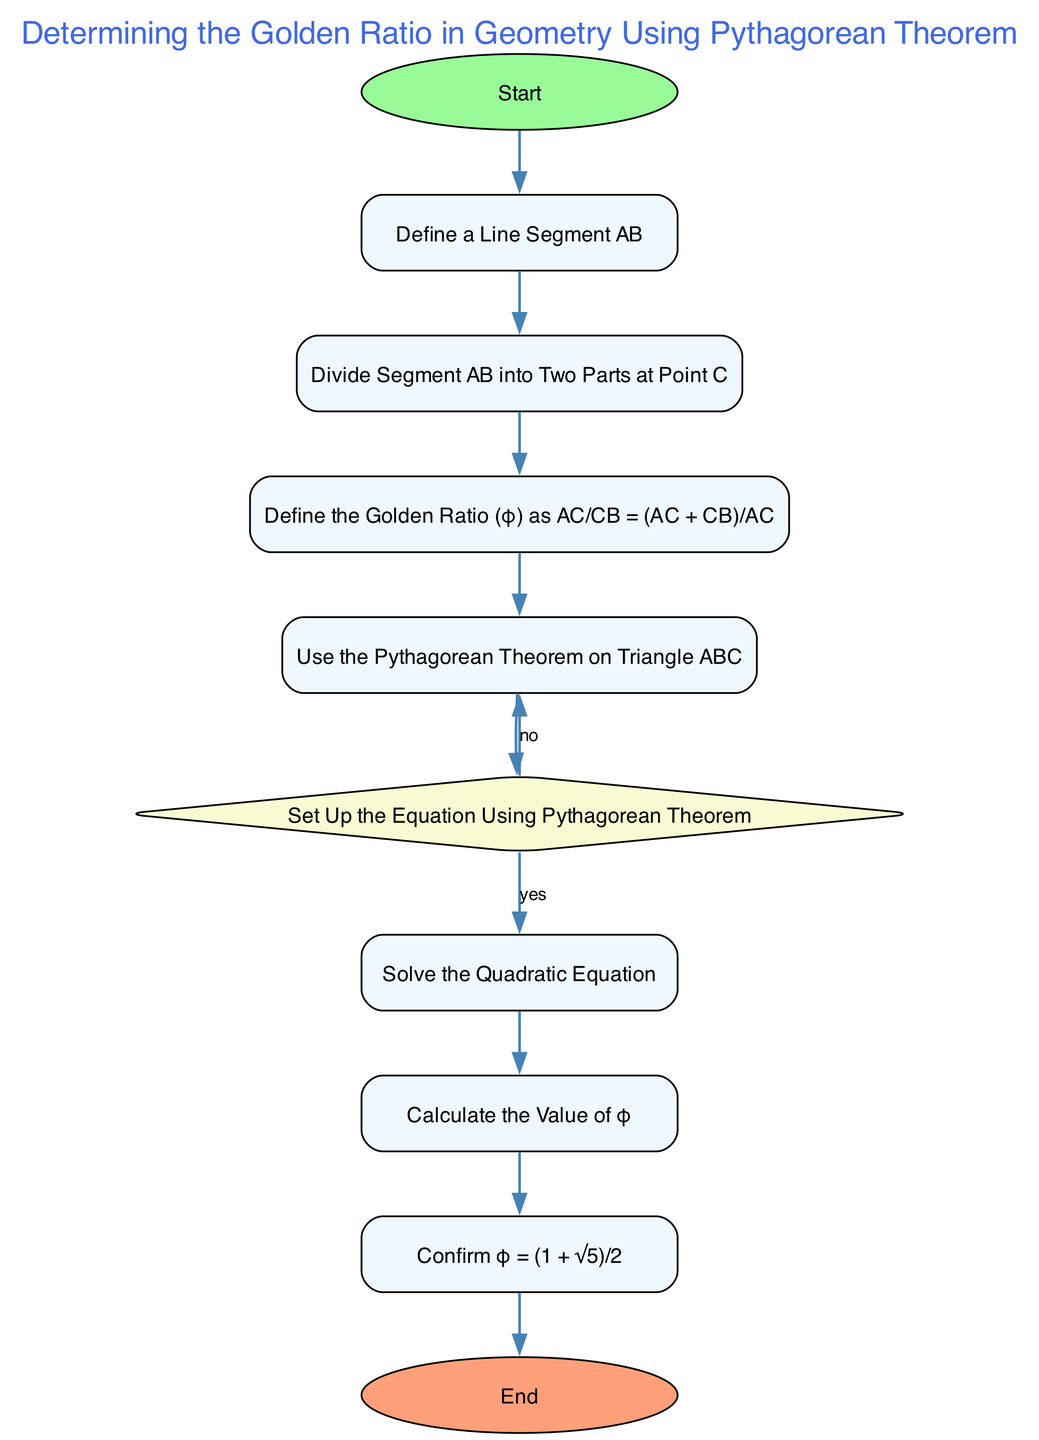What is the first step in the flowchart? The first step is labeled "Start." This is where the process begins in the flowchart.
Answer: Start How many process steps are in the diagram? The diagram contains six process steps: "Define a Line Segment AB," "Divide Segment AB into Two Parts at Point C," "Define the Golden Ratio (φ) as AC/CB = (AC + CB)/AC," "Use the Pythagorean Theorem on Triangle ABC," "Solve the Quadratic Equation," and "Calculate the Value of φ." Therefore, the total is six.
Answer: Six What action follows defining the golden ratio? Following the defining of the golden ratio, the next action is "Use the Pythagorean Theorem on Triangle ABC," which is the subsequent step in the diagram.
Answer: Use the Pythagorean Theorem on Triangle ABC What does the decision node lead to if the answer is "yes"? If the answer to the decision question at the "Set Up the Equation Using Pythagorean Theorem" node is "yes," it leads to the "Solve the Quadratic Equation" process step.
Answer: Solve the Quadratic Equation What is the final output of the flowchart? The final output of the flowchart is "Confirm φ = (1 + √5)/2," which is the last process before the end of the flowchart.
Answer: Confirm φ = (1 + √5)/2 If the outcome from the equation setup is "no," what is the next step? If the outcome from the decision node is "no," it revisits the "Use the Pythagorean Theorem on Triangle ABC," requiring reevaluation of the previous steps.
Answer: Use the Pythagorean Theorem on Triangle ABC Which mathematical theorem is employed in this process? The Pythagorean Theorem is employed, as indicated in the flowchart that specifies using it for Triangle ABC.
Answer: Pythagorean Theorem How is the golden ratio defined in the diagram? The golden ratio is defined as "AC/CB = (AC + CB)/AC," which is specified in one of the process steps.
Answer: AC/CB = (AC + CB)/AC 